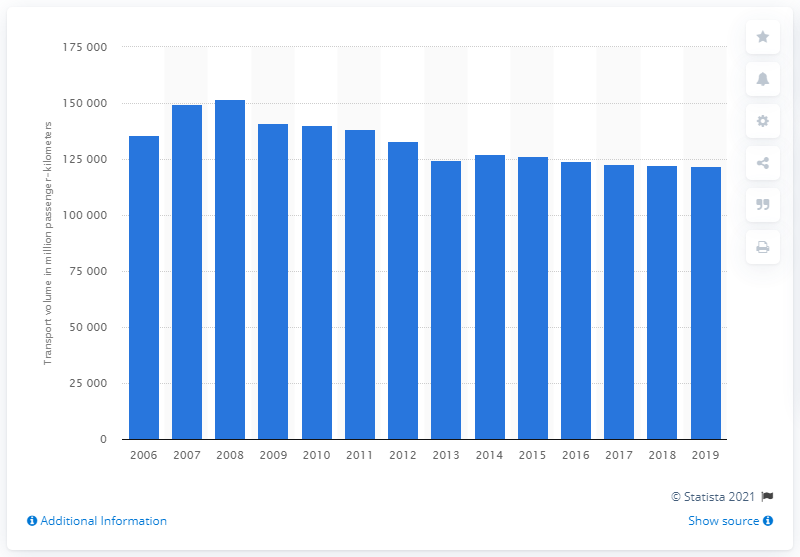Point out several critical features in this image. In 2019, the lowest passenger volume recorded in Russia was 121,942. In 2008, the volume of passenger-kilometers recorded was the highest at 151,774. 